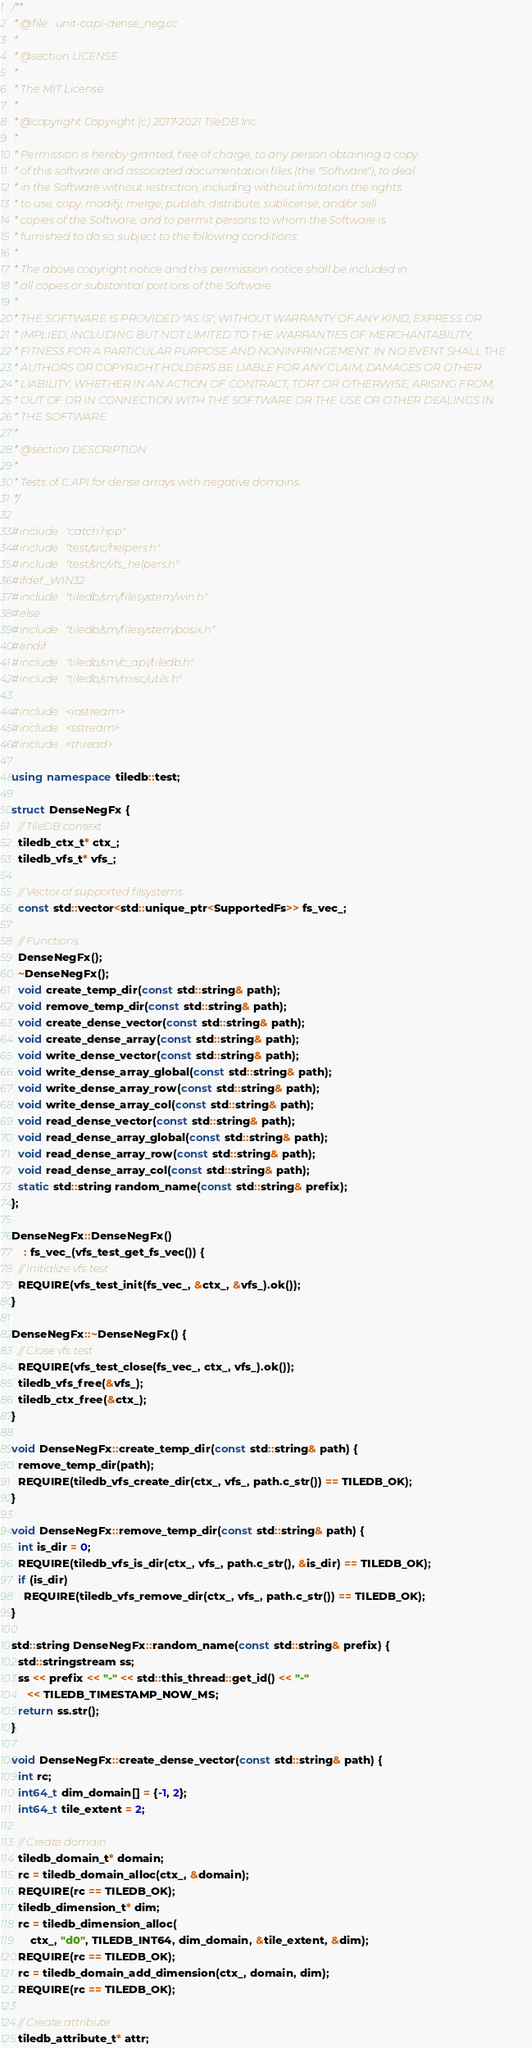<code> <loc_0><loc_0><loc_500><loc_500><_C++_>/**
 * @file   unit-capi-dense_neg.cc
 *
 * @section LICENSE
 *
 * The MIT License
 *
 * @copyright Copyright (c) 2017-2021 TileDB Inc.
 *
 * Permission is hereby granted, free of charge, to any person obtaining a copy
 * of this software and associated documentation files (the "Software"), to deal
 * in the Software without restriction, including without limitation the rights
 * to use, copy, modify, merge, publish, distribute, sublicense, and/or sell
 * copies of the Software, and to permit persons to whom the Software is
 * furnished to do so, subject to the following conditions:
 *
 * The above copyright notice and this permission notice shall be included in
 * all copies or substantial portions of the Software.
 *
 * THE SOFTWARE IS PROVIDED "AS IS", WITHOUT WARRANTY OF ANY KIND, EXPRESS OR
 * IMPLIED, INCLUDING BUT NOT LIMITED TO THE WARRANTIES OF MERCHANTABILITY,
 * FITNESS FOR A PARTICULAR PURPOSE AND NONINFRINGEMENT. IN NO EVENT SHALL THE
 * AUTHORS OR COPYRIGHT HOLDERS BE LIABLE FOR ANY CLAIM, DAMAGES OR OTHER
 * LIABILITY, WHETHER IN AN ACTION OF CONTRACT, TORT OR OTHERWISE, ARISING FROM,
 * OUT OF OR IN CONNECTION WITH THE SOFTWARE OR THE USE OR OTHER DEALINGS IN
 * THE SOFTWARE.
 *
 * @section DESCRIPTION
 *
 * Tests of C API for dense arrays with negative domains.
 */

#include "catch.hpp"
#include "test/src/helpers.h"
#include "test/src/vfs_helpers.h"
#ifdef _WIN32
#include "tiledb/sm/filesystem/win.h"
#else
#include "tiledb/sm/filesystem/posix.h"
#endif
#include "tiledb/sm/c_api/tiledb.h"
#include "tiledb/sm/misc/utils.h"

#include <iostream>
#include <sstream>
#include <thread>

using namespace tiledb::test;

struct DenseNegFx {
  // TileDB context
  tiledb_ctx_t* ctx_;
  tiledb_vfs_t* vfs_;

  // Vector of supported filsystems
  const std::vector<std::unique_ptr<SupportedFs>> fs_vec_;

  // Functions
  DenseNegFx();
  ~DenseNegFx();
  void create_temp_dir(const std::string& path);
  void remove_temp_dir(const std::string& path);
  void create_dense_vector(const std::string& path);
  void create_dense_array(const std::string& path);
  void write_dense_vector(const std::string& path);
  void write_dense_array_global(const std::string& path);
  void write_dense_array_row(const std::string& path);
  void write_dense_array_col(const std::string& path);
  void read_dense_vector(const std::string& path);
  void read_dense_array_global(const std::string& path);
  void read_dense_array_row(const std::string& path);
  void read_dense_array_col(const std::string& path);
  static std::string random_name(const std::string& prefix);
};

DenseNegFx::DenseNegFx()
    : fs_vec_(vfs_test_get_fs_vec()) {
  // Initialize vfs test
  REQUIRE(vfs_test_init(fs_vec_, &ctx_, &vfs_).ok());
}

DenseNegFx::~DenseNegFx() {
  // Close vfs test
  REQUIRE(vfs_test_close(fs_vec_, ctx_, vfs_).ok());
  tiledb_vfs_free(&vfs_);
  tiledb_ctx_free(&ctx_);
}

void DenseNegFx::create_temp_dir(const std::string& path) {
  remove_temp_dir(path);
  REQUIRE(tiledb_vfs_create_dir(ctx_, vfs_, path.c_str()) == TILEDB_OK);
}

void DenseNegFx::remove_temp_dir(const std::string& path) {
  int is_dir = 0;
  REQUIRE(tiledb_vfs_is_dir(ctx_, vfs_, path.c_str(), &is_dir) == TILEDB_OK);
  if (is_dir)
    REQUIRE(tiledb_vfs_remove_dir(ctx_, vfs_, path.c_str()) == TILEDB_OK);
}

std::string DenseNegFx::random_name(const std::string& prefix) {
  std::stringstream ss;
  ss << prefix << "-" << std::this_thread::get_id() << "-"
     << TILEDB_TIMESTAMP_NOW_MS;
  return ss.str();
}

void DenseNegFx::create_dense_vector(const std::string& path) {
  int rc;
  int64_t dim_domain[] = {-1, 2};
  int64_t tile_extent = 2;

  // Create domain
  tiledb_domain_t* domain;
  rc = tiledb_domain_alloc(ctx_, &domain);
  REQUIRE(rc == TILEDB_OK);
  tiledb_dimension_t* dim;
  rc = tiledb_dimension_alloc(
      ctx_, "d0", TILEDB_INT64, dim_domain, &tile_extent, &dim);
  REQUIRE(rc == TILEDB_OK);
  rc = tiledb_domain_add_dimension(ctx_, domain, dim);
  REQUIRE(rc == TILEDB_OK);

  // Create attribute
  tiledb_attribute_t* attr;</code> 